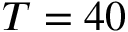Convert formula to latex. <formula><loc_0><loc_0><loc_500><loc_500>T = 4 0</formula> 